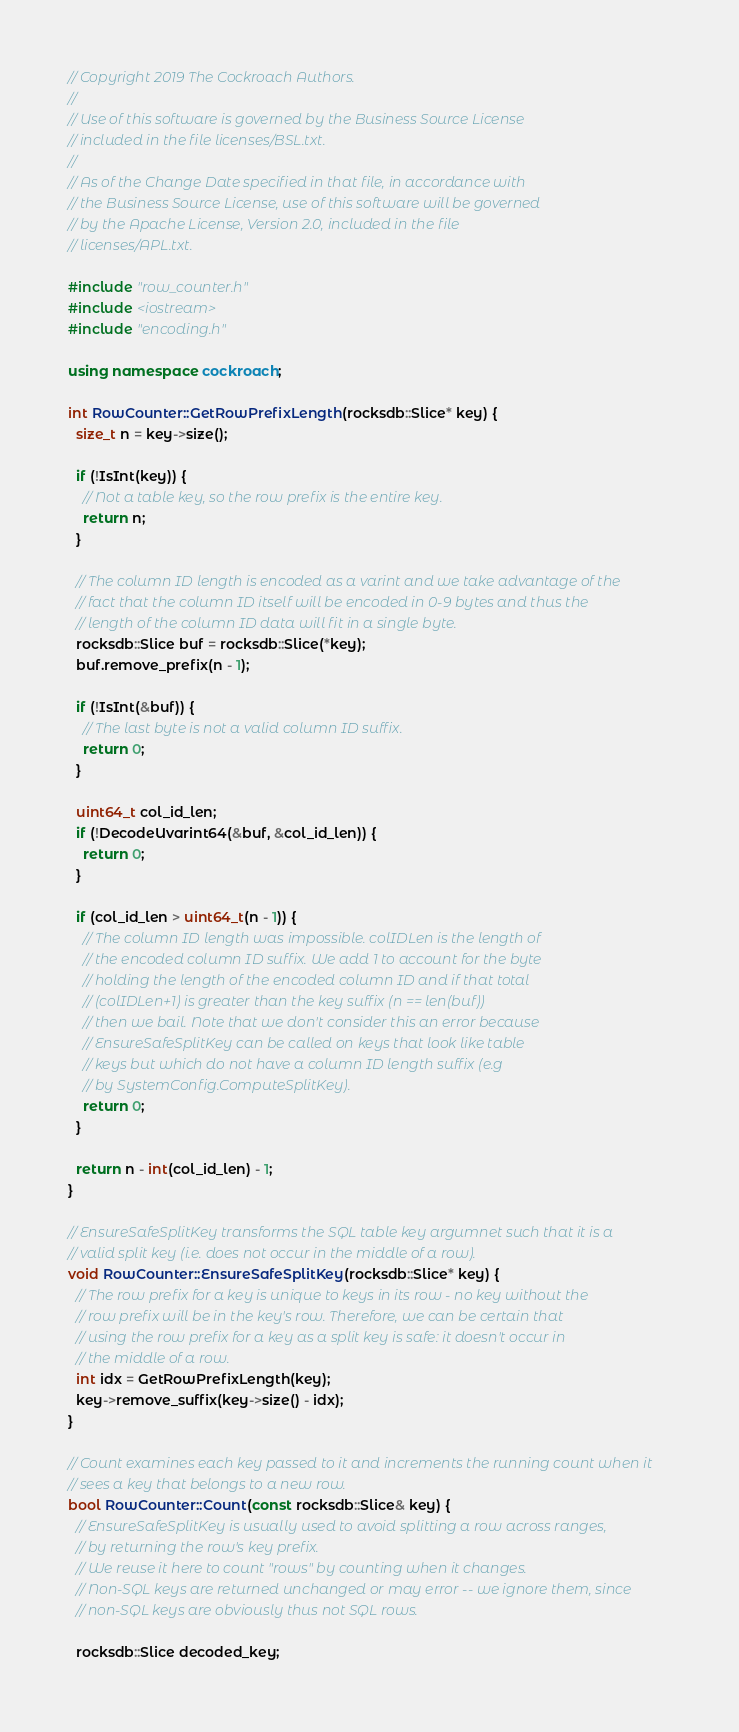<code> <loc_0><loc_0><loc_500><loc_500><_C++_>// Copyright 2019 The Cockroach Authors.
//
// Use of this software is governed by the Business Source License
// included in the file licenses/BSL.txt.
//
// As of the Change Date specified in that file, in accordance with
// the Business Source License, use of this software will be governed
// by the Apache License, Version 2.0, included in the file
// licenses/APL.txt.

#include "row_counter.h"
#include <iostream>
#include "encoding.h"

using namespace cockroach;

int RowCounter::GetRowPrefixLength(rocksdb::Slice* key) {
  size_t n = key->size();

  if (!IsInt(key)) {
    // Not a table key, so the row prefix is the entire key.
    return n;
  }

  // The column ID length is encoded as a varint and we take advantage of the
  // fact that the column ID itself will be encoded in 0-9 bytes and thus the
  // length of the column ID data will fit in a single byte.
  rocksdb::Slice buf = rocksdb::Slice(*key);
  buf.remove_prefix(n - 1);

  if (!IsInt(&buf)) {
    // The last byte is not a valid column ID suffix.
    return 0;
  }

  uint64_t col_id_len;
  if (!DecodeUvarint64(&buf, &col_id_len)) {
    return 0;
  }

  if (col_id_len > uint64_t(n - 1)) {
    // The column ID length was impossible. colIDLen is the length of
    // the encoded column ID suffix. We add 1 to account for the byte
    // holding the length of the encoded column ID and if that total
    // (colIDLen+1) is greater than the key suffix (n == len(buf))
    // then we bail. Note that we don't consider this an error because
    // EnsureSafeSplitKey can be called on keys that look like table
    // keys but which do not have a column ID length suffix (e.g
    // by SystemConfig.ComputeSplitKey).
    return 0;
  }

  return n - int(col_id_len) - 1;
}

// EnsureSafeSplitKey transforms the SQL table key argumnet such that it is a
// valid split key (i.e. does not occur in the middle of a row).
void RowCounter::EnsureSafeSplitKey(rocksdb::Slice* key) {
  // The row prefix for a key is unique to keys in its row - no key without the
  // row prefix will be in the key's row. Therefore, we can be certain that
  // using the row prefix for a key as a split key is safe: it doesn't occur in
  // the middle of a row.
  int idx = GetRowPrefixLength(key);
  key->remove_suffix(key->size() - idx);
}

// Count examines each key passed to it and increments the running count when it
// sees a key that belongs to a new row.
bool RowCounter::Count(const rocksdb::Slice& key) {
  // EnsureSafeSplitKey is usually used to avoid splitting a row across ranges,
  // by returning the row's key prefix.
  // We reuse it here to count "rows" by counting when it changes.
  // Non-SQL keys are returned unchanged or may error -- we ignore them, since
  // non-SQL keys are obviously thus not SQL rows.

  rocksdb::Slice decoded_key;</code> 